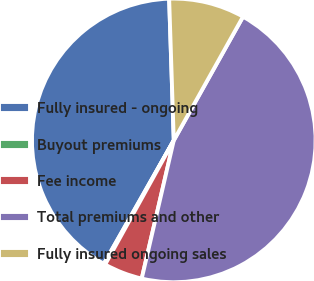Convert chart to OTSL. <chart><loc_0><loc_0><loc_500><loc_500><pie_chart><fcel>Fully insured - ongoing<fcel>Buyout premiums<fcel>Fee income<fcel>Total premiums and other<fcel>Fully insured ongoing sales<nl><fcel>41.27%<fcel>0.17%<fcel>4.41%<fcel>45.51%<fcel>8.64%<nl></chart> 